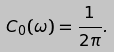Convert formula to latex. <formula><loc_0><loc_0><loc_500><loc_500>C _ { 0 } ( \omega ) = \frac { 1 } { 2 \pi } .</formula> 